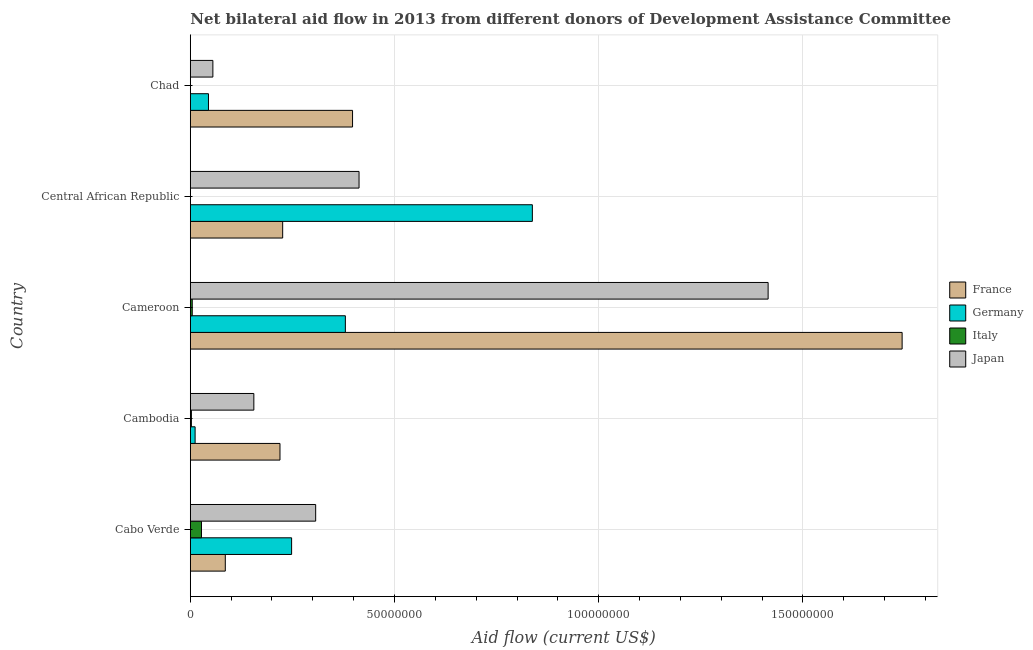How many different coloured bars are there?
Provide a short and direct response. 4. How many groups of bars are there?
Provide a short and direct response. 5. Are the number of bars per tick equal to the number of legend labels?
Give a very brief answer. No. How many bars are there on the 4th tick from the bottom?
Offer a terse response. 3. What is the label of the 5th group of bars from the top?
Your response must be concise. Cabo Verde. In how many cases, is the number of bars for a given country not equal to the number of legend labels?
Provide a succinct answer. 2. What is the amount of aid given by germany in Cambodia?
Make the answer very short. 1.18e+06. Across all countries, what is the maximum amount of aid given by japan?
Offer a very short reply. 1.41e+08. Across all countries, what is the minimum amount of aid given by germany?
Your response must be concise. 1.18e+06. In which country was the amount of aid given by germany maximum?
Keep it short and to the point. Central African Republic. What is the total amount of aid given by france in the graph?
Your response must be concise. 2.67e+08. What is the difference between the amount of aid given by france in Cameroon and that in Chad?
Your response must be concise. 1.35e+08. What is the difference between the amount of aid given by france in Central African Republic and the amount of aid given by germany in Chad?
Your answer should be compact. 1.82e+07. What is the average amount of aid given by japan per country?
Provide a succinct answer. 4.69e+07. What is the difference between the amount of aid given by germany and amount of aid given by japan in Cambodia?
Keep it short and to the point. -1.44e+07. What is the ratio of the amount of aid given by germany in Cabo Verde to that in Cambodia?
Offer a very short reply. 21.02. What is the difference between the highest and the second highest amount of aid given by italy?
Ensure brevity in your answer.  2.26e+06. What is the difference between the highest and the lowest amount of aid given by france?
Provide a short and direct response. 1.66e+08. In how many countries, is the amount of aid given by germany greater than the average amount of aid given by germany taken over all countries?
Your answer should be compact. 2. Are all the bars in the graph horizontal?
Provide a short and direct response. Yes. How many countries are there in the graph?
Make the answer very short. 5. What is the difference between two consecutive major ticks on the X-axis?
Provide a succinct answer. 5.00e+07. Are the values on the major ticks of X-axis written in scientific E-notation?
Give a very brief answer. No. Does the graph contain any zero values?
Make the answer very short. Yes. How many legend labels are there?
Make the answer very short. 4. How are the legend labels stacked?
Your response must be concise. Vertical. What is the title of the graph?
Provide a short and direct response. Net bilateral aid flow in 2013 from different donors of Development Assistance Committee. Does "Coal" appear as one of the legend labels in the graph?
Provide a succinct answer. No. What is the label or title of the Y-axis?
Offer a very short reply. Country. What is the Aid flow (current US$) of France in Cabo Verde?
Keep it short and to the point. 8.57e+06. What is the Aid flow (current US$) in Germany in Cabo Verde?
Offer a terse response. 2.48e+07. What is the Aid flow (current US$) in Italy in Cabo Verde?
Your answer should be compact. 2.74e+06. What is the Aid flow (current US$) in Japan in Cabo Verde?
Your answer should be very brief. 3.07e+07. What is the Aid flow (current US$) of France in Cambodia?
Ensure brevity in your answer.  2.20e+07. What is the Aid flow (current US$) in Germany in Cambodia?
Your answer should be compact. 1.18e+06. What is the Aid flow (current US$) of Japan in Cambodia?
Provide a succinct answer. 1.56e+07. What is the Aid flow (current US$) of France in Cameroon?
Ensure brevity in your answer.  1.74e+08. What is the Aid flow (current US$) in Germany in Cameroon?
Give a very brief answer. 3.80e+07. What is the Aid flow (current US$) of Japan in Cameroon?
Your answer should be very brief. 1.41e+08. What is the Aid flow (current US$) of France in Central African Republic?
Keep it short and to the point. 2.26e+07. What is the Aid flow (current US$) in Germany in Central African Republic?
Offer a terse response. 8.38e+07. What is the Aid flow (current US$) in Italy in Central African Republic?
Give a very brief answer. 0. What is the Aid flow (current US$) of Japan in Central African Republic?
Your answer should be very brief. 4.13e+07. What is the Aid flow (current US$) in France in Chad?
Keep it short and to the point. 3.97e+07. What is the Aid flow (current US$) of Germany in Chad?
Provide a succinct answer. 4.45e+06. What is the Aid flow (current US$) in Japan in Chad?
Provide a succinct answer. 5.53e+06. Across all countries, what is the maximum Aid flow (current US$) in France?
Offer a very short reply. 1.74e+08. Across all countries, what is the maximum Aid flow (current US$) of Germany?
Your answer should be compact. 8.38e+07. Across all countries, what is the maximum Aid flow (current US$) of Italy?
Your response must be concise. 2.74e+06. Across all countries, what is the maximum Aid flow (current US$) in Japan?
Offer a very short reply. 1.41e+08. Across all countries, what is the minimum Aid flow (current US$) of France?
Provide a succinct answer. 8.57e+06. Across all countries, what is the minimum Aid flow (current US$) of Germany?
Your answer should be compact. 1.18e+06. Across all countries, what is the minimum Aid flow (current US$) in Italy?
Provide a succinct answer. 0. Across all countries, what is the minimum Aid flow (current US$) of Japan?
Offer a very short reply. 5.53e+06. What is the total Aid flow (current US$) of France in the graph?
Offer a terse response. 2.67e+08. What is the total Aid flow (current US$) of Germany in the graph?
Your answer should be very brief. 1.52e+08. What is the total Aid flow (current US$) of Italy in the graph?
Keep it short and to the point. 3.49e+06. What is the total Aid flow (current US$) in Japan in the graph?
Make the answer very short. 2.35e+08. What is the difference between the Aid flow (current US$) of France in Cabo Verde and that in Cambodia?
Offer a terse response. -1.34e+07. What is the difference between the Aid flow (current US$) in Germany in Cabo Verde and that in Cambodia?
Offer a terse response. 2.36e+07. What is the difference between the Aid flow (current US$) in Italy in Cabo Verde and that in Cambodia?
Provide a short and direct response. 2.47e+06. What is the difference between the Aid flow (current US$) of Japan in Cabo Verde and that in Cambodia?
Your answer should be very brief. 1.51e+07. What is the difference between the Aid flow (current US$) of France in Cabo Verde and that in Cameroon?
Give a very brief answer. -1.66e+08. What is the difference between the Aid flow (current US$) of Germany in Cabo Verde and that in Cameroon?
Keep it short and to the point. -1.32e+07. What is the difference between the Aid flow (current US$) of Italy in Cabo Verde and that in Cameroon?
Make the answer very short. 2.26e+06. What is the difference between the Aid flow (current US$) in Japan in Cabo Verde and that in Cameroon?
Your answer should be compact. -1.11e+08. What is the difference between the Aid flow (current US$) of France in Cabo Verde and that in Central African Republic?
Your answer should be compact. -1.40e+07. What is the difference between the Aid flow (current US$) of Germany in Cabo Verde and that in Central African Republic?
Make the answer very short. -5.90e+07. What is the difference between the Aid flow (current US$) of Japan in Cabo Verde and that in Central African Republic?
Provide a short and direct response. -1.06e+07. What is the difference between the Aid flow (current US$) in France in Cabo Verde and that in Chad?
Provide a succinct answer. -3.12e+07. What is the difference between the Aid flow (current US$) of Germany in Cabo Verde and that in Chad?
Provide a short and direct response. 2.04e+07. What is the difference between the Aid flow (current US$) in Japan in Cabo Verde and that in Chad?
Keep it short and to the point. 2.52e+07. What is the difference between the Aid flow (current US$) in France in Cambodia and that in Cameroon?
Ensure brevity in your answer.  -1.52e+08. What is the difference between the Aid flow (current US$) of Germany in Cambodia and that in Cameroon?
Your answer should be very brief. -3.68e+07. What is the difference between the Aid flow (current US$) of Japan in Cambodia and that in Cameroon?
Offer a very short reply. -1.26e+08. What is the difference between the Aid flow (current US$) of France in Cambodia and that in Central African Republic?
Make the answer very short. -6.60e+05. What is the difference between the Aid flow (current US$) of Germany in Cambodia and that in Central African Republic?
Your response must be concise. -8.26e+07. What is the difference between the Aid flow (current US$) of Japan in Cambodia and that in Central African Republic?
Make the answer very short. -2.58e+07. What is the difference between the Aid flow (current US$) in France in Cambodia and that in Chad?
Ensure brevity in your answer.  -1.78e+07. What is the difference between the Aid flow (current US$) in Germany in Cambodia and that in Chad?
Provide a succinct answer. -3.27e+06. What is the difference between the Aid flow (current US$) of Japan in Cambodia and that in Chad?
Provide a short and direct response. 1.00e+07. What is the difference between the Aid flow (current US$) in France in Cameroon and that in Central African Republic?
Keep it short and to the point. 1.52e+08. What is the difference between the Aid flow (current US$) in Germany in Cameroon and that in Central African Republic?
Provide a succinct answer. -4.58e+07. What is the difference between the Aid flow (current US$) of Japan in Cameroon and that in Central African Republic?
Your answer should be compact. 1.00e+08. What is the difference between the Aid flow (current US$) in France in Cameroon and that in Chad?
Your response must be concise. 1.35e+08. What is the difference between the Aid flow (current US$) in Germany in Cameroon and that in Chad?
Offer a very short reply. 3.35e+07. What is the difference between the Aid flow (current US$) of Japan in Cameroon and that in Chad?
Make the answer very short. 1.36e+08. What is the difference between the Aid flow (current US$) in France in Central African Republic and that in Chad?
Your answer should be compact. -1.71e+07. What is the difference between the Aid flow (current US$) in Germany in Central African Republic and that in Chad?
Your response must be concise. 7.93e+07. What is the difference between the Aid flow (current US$) of Japan in Central African Republic and that in Chad?
Make the answer very short. 3.58e+07. What is the difference between the Aid flow (current US$) in France in Cabo Verde and the Aid flow (current US$) in Germany in Cambodia?
Offer a very short reply. 7.39e+06. What is the difference between the Aid flow (current US$) in France in Cabo Verde and the Aid flow (current US$) in Italy in Cambodia?
Your answer should be very brief. 8.30e+06. What is the difference between the Aid flow (current US$) of France in Cabo Verde and the Aid flow (current US$) of Japan in Cambodia?
Your answer should be very brief. -6.99e+06. What is the difference between the Aid flow (current US$) of Germany in Cabo Verde and the Aid flow (current US$) of Italy in Cambodia?
Provide a succinct answer. 2.45e+07. What is the difference between the Aid flow (current US$) in Germany in Cabo Verde and the Aid flow (current US$) in Japan in Cambodia?
Keep it short and to the point. 9.25e+06. What is the difference between the Aid flow (current US$) of Italy in Cabo Verde and the Aid flow (current US$) of Japan in Cambodia?
Keep it short and to the point. -1.28e+07. What is the difference between the Aid flow (current US$) in France in Cabo Verde and the Aid flow (current US$) in Germany in Cameroon?
Ensure brevity in your answer.  -2.94e+07. What is the difference between the Aid flow (current US$) of France in Cabo Verde and the Aid flow (current US$) of Italy in Cameroon?
Ensure brevity in your answer.  8.09e+06. What is the difference between the Aid flow (current US$) of France in Cabo Verde and the Aid flow (current US$) of Japan in Cameroon?
Ensure brevity in your answer.  -1.33e+08. What is the difference between the Aid flow (current US$) of Germany in Cabo Verde and the Aid flow (current US$) of Italy in Cameroon?
Your response must be concise. 2.43e+07. What is the difference between the Aid flow (current US$) of Germany in Cabo Verde and the Aid flow (current US$) of Japan in Cameroon?
Make the answer very short. -1.17e+08. What is the difference between the Aid flow (current US$) in Italy in Cabo Verde and the Aid flow (current US$) in Japan in Cameroon?
Give a very brief answer. -1.39e+08. What is the difference between the Aid flow (current US$) of France in Cabo Verde and the Aid flow (current US$) of Germany in Central African Republic?
Your response must be concise. -7.52e+07. What is the difference between the Aid flow (current US$) of France in Cabo Verde and the Aid flow (current US$) of Japan in Central African Republic?
Provide a short and direct response. -3.28e+07. What is the difference between the Aid flow (current US$) in Germany in Cabo Verde and the Aid flow (current US$) in Japan in Central African Republic?
Offer a very short reply. -1.65e+07. What is the difference between the Aid flow (current US$) of Italy in Cabo Verde and the Aid flow (current US$) of Japan in Central African Republic?
Your answer should be compact. -3.86e+07. What is the difference between the Aid flow (current US$) of France in Cabo Verde and the Aid flow (current US$) of Germany in Chad?
Your answer should be compact. 4.12e+06. What is the difference between the Aid flow (current US$) of France in Cabo Verde and the Aid flow (current US$) of Japan in Chad?
Offer a very short reply. 3.04e+06. What is the difference between the Aid flow (current US$) of Germany in Cabo Verde and the Aid flow (current US$) of Japan in Chad?
Keep it short and to the point. 1.93e+07. What is the difference between the Aid flow (current US$) in Italy in Cabo Verde and the Aid flow (current US$) in Japan in Chad?
Your answer should be compact. -2.79e+06. What is the difference between the Aid flow (current US$) of France in Cambodia and the Aid flow (current US$) of Germany in Cameroon?
Your response must be concise. -1.60e+07. What is the difference between the Aid flow (current US$) in France in Cambodia and the Aid flow (current US$) in Italy in Cameroon?
Offer a terse response. 2.15e+07. What is the difference between the Aid flow (current US$) of France in Cambodia and the Aid flow (current US$) of Japan in Cameroon?
Offer a very short reply. -1.20e+08. What is the difference between the Aid flow (current US$) in Germany in Cambodia and the Aid flow (current US$) in Japan in Cameroon?
Your answer should be very brief. -1.40e+08. What is the difference between the Aid flow (current US$) in Italy in Cambodia and the Aid flow (current US$) in Japan in Cameroon?
Offer a very short reply. -1.41e+08. What is the difference between the Aid flow (current US$) in France in Cambodia and the Aid flow (current US$) in Germany in Central African Republic?
Your answer should be very brief. -6.18e+07. What is the difference between the Aid flow (current US$) of France in Cambodia and the Aid flow (current US$) of Japan in Central African Republic?
Your response must be concise. -1.94e+07. What is the difference between the Aid flow (current US$) in Germany in Cambodia and the Aid flow (current US$) in Japan in Central African Republic?
Give a very brief answer. -4.01e+07. What is the difference between the Aid flow (current US$) in Italy in Cambodia and the Aid flow (current US$) in Japan in Central African Republic?
Your response must be concise. -4.10e+07. What is the difference between the Aid flow (current US$) of France in Cambodia and the Aid flow (current US$) of Germany in Chad?
Provide a short and direct response. 1.75e+07. What is the difference between the Aid flow (current US$) in France in Cambodia and the Aid flow (current US$) in Japan in Chad?
Ensure brevity in your answer.  1.64e+07. What is the difference between the Aid flow (current US$) of Germany in Cambodia and the Aid flow (current US$) of Japan in Chad?
Provide a short and direct response. -4.35e+06. What is the difference between the Aid flow (current US$) of Italy in Cambodia and the Aid flow (current US$) of Japan in Chad?
Provide a succinct answer. -5.26e+06. What is the difference between the Aid flow (current US$) in France in Cameroon and the Aid flow (current US$) in Germany in Central African Republic?
Ensure brevity in your answer.  9.05e+07. What is the difference between the Aid flow (current US$) in France in Cameroon and the Aid flow (current US$) in Japan in Central African Republic?
Offer a terse response. 1.33e+08. What is the difference between the Aid flow (current US$) of Germany in Cameroon and the Aid flow (current US$) of Japan in Central African Republic?
Your answer should be very brief. -3.35e+06. What is the difference between the Aid flow (current US$) of Italy in Cameroon and the Aid flow (current US$) of Japan in Central African Republic?
Ensure brevity in your answer.  -4.08e+07. What is the difference between the Aid flow (current US$) of France in Cameroon and the Aid flow (current US$) of Germany in Chad?
Ensure brevity in your answer.  1.70e+08. What is the difference between the Aid flow (current US$) of France in Cameroon and the Aid flow (current US$) of Japan in Chad?
Keep it short and to the point. 1.69e+08. What is the difference between the Aid flow (current US$) in Germany in Cameroon and the Aid flow (current US$) in Japan in Chad?
Ensure brevity in your answer.  3.24e+07. What is the difference between the Aid flow (current US$) in Italy in Cameroon and the Aid flow (current US$) in Japan in Chad?
Your answer should be very brief. -5.05e+06. What is the difference between the Aid flow (current US$) of France in Central African Republic and the Aid flow (current US$) of Germany in Chad?
Keep it short and to the point. 1.82e+07. What is the difference between the Aid flow (current US$) of France in Central African Republic and the Aid flow (current US$) of Japan in Chad?
Make the answer very short. 1.71e+07. What is the difference between the Aid flow (current US$) of Germany in Central African Republic and the Aid flow (current US$) of Japan in Chad?
Offer a terse response. 7.82e+07. What is the average Aid flow (current US$) of France per country?
Provide a short and direct response. 5.34e+07. What is the average Aid flow (current US$) of Germany per country?
Provide a short and direct response. 3.04e+07. What is the average Aid flow (current US$) in Italy per country?
Your response must be concise. 6.98e+05. What is the average Aid flow (current US$) in Japan per country?
Your answer should be very brief. 4.69e+07. What is the difference between the Aid flow (current US$) in France and Aid flow (current US$) in Germany in Cabo Verde?
Provide a short and direct response. -1.62e+07. What is the difference between the Aid flow (current US$) of France and Aid flow (current US$) of Italy in Cabo Verde?
Ensure brevity in your answer.  5.83e+06. What is the difference between the Aid flow (current US$) in France and Aid flow (current US$) in Japan in Cabo Verde?
Your response must be concise. -2.21e+07. What is the difference between the Aid flow (current US$) of Germany and Aid flow (current US$) of Italy in Cabo Verde?
Keep it short and to the point. 2.21e+07. What is the difference between the Aid flow (current US$) in Germany and Aid flow (current US$) in Japan in Cabo Verde?
Offer a very short reply. -5.89e+06. What is the difference between the Aid flow (current US$) of Italy and Aid flow (current US$) of Japan in Cabo Verde?
Provide a short and direct response. -2.80e+07. What is the difference between the Aid flow (current US$) in France and Aid flow (current US$) in Germany in Cambodia?
Provide a short and direct response. 2.08e+07. What is the difference between the Aid flow (current US$) of France and Aid flow (current US$) of Italy in Cambodia?
Provide a short and direct response. 2.17e+07. What is the difference between the Aid flow (current US$) in France and Aid flow (current US$) in Japan in Cambodia?
Offer a very short reply. 6.40e+06. What is the difference between the Aid flow (current US$) of Germany and Aid flow (current US$) of Italy in Cambodia?
Your answer should be compact. 9.10e+05. What is the difference between the Aid flow (current US$) of Germany and Aid flow (current US$) of Japan in Cambodia?
Your response must be concise. -1.44e+07. What is the difference between the Aid flow (current US$) of Italy and Aid flow (current US$) of Japan in Cambodia?
Provide a short and direct response. -1.53e+07. What is the difference between the Aid flow (current US$) of France and Aid flow (current US$) of Germany in Cameroon?
Keep it short and to the point. 1.36e+08. What is the difference between the Aid flow (current US$) of France and Aid flow (current US$) of Italy in Cameroon?
Keep it short and to the point. 1.74e+08. What is the difference between the Aid flow (current US$) in France and Aid flow (current US$) in Japan in Cameroon?
Offer a very short reply. 3.28e+07. What is the difference between the Aid flow (current US$) in Germany and Aid flow (current US$) in Italy in Cameroon?
Your answer should be compact. 3.75e+07. What is the difference between the Aid flow (current US$) of Germany and Aid flow (current US$) of Japan in Cameroon?
Your answer should be compact. -1.04e+08. What is the difference between the Aid flow (current US$) of Italy and Aid flow (current US$) of Japan in Cameroon?
Offer a terse response. -1.41e+08. What is the difference between the Aid flow (current US$) in France and Aid flow (current US$) in Germany in Central African Republic?
Ensure brevity in your answer.  -6.11e+07. What is the difference between the Aid flow (current US$) of France and Aid flow (current US$) of Japan in Central African Republic?
Keep it short and to the point. -1.87e+07. What is the difference between the Aid flow (current US$) in Germany and Aid flow (current US$) in Japan in Central African Republic?
Make the answer very short. 4.24e+07. What is the difference between the Aid flow (current US$) of France and Aid flow (current US$) of Germany in Chad?
Provide a succinct answer. 3.53e+07. What is the difference between the Aid flow (current US$) of France and Aid flow (current US$) of Japan in Chad?
Offer a very short reply. 3.42e+07. What is the difference between the Aid flow (current US$) of Germany and Aid flow (current US$) of Japan in Chad?
Offer a terse response. -1.08e+06. What is the ratio of the Aid flow (current US$) in France in Cabo Verde to that in Cambodia?
Your answer should be very brief. 0.39. What is the ratio of the Aid flow (current US$) in Germany in Cabo Verde to that in Cambodia?
Offer a terse response. 21.03. What is the ratio of the Aid flow (current US$) of Italy in Cabo Verde to that in Cambodia?
Give a very brief answer. 10.15. What is the ratio of the Aid flow (current US$) in Japan in Cabo Verde to that in Cambodia?
Provide a succinct answer. 1.97. What is the ratio of the Aid flow (current US$) in France in Cabo Verde to that in Cameroon?
Make the answer very short. 0.05. What is the ratio of the Aid flow (current US$) in Germany in Cabo Verde to that in Cameroon?
Keep it short and to the point. 0.65. What is the ratio of the Aid flow (current US$) in Italy in Cabo Verde to that in Cameroon?
Make the answer very short. 5.71. What is the ratio of the Aid flow (current US$) of Japan in Cabo Verde to that in Cameroon?
Offer a terse response. 0.22. What is the ratio of the Aid flow (current US$) of France in Cabo Verde to that in Central African Republic?
Provide a short and direct response. 0.38. What is the ratio of the Aid flow (current US$) of Germany in Cabo Verde to that in Central African Republic?
Provide a short and direct response. 0.3. What is the ratio of the Aid flow (current US$) of Japan in Cabo Verde to that in Central African Republic?
Give a very brief answer. 0.74. What is the ratio of the Aid flow (current US$) in France in Cabo Verde to that in Chad?
Provide a short and direct response. 0.22. What is the ratio of the Aid flow (current US$) in Germany in Cabo Verde to that in Chad?
Your answer should be very brief. 5.58. What is the ratio of the Aid flow (current US$) in Japan in Cabo Verde to that in Chad?
Your answer should be compact. 5.55. What is the ratio of the Aid flow (current US$) in France in Cambodia to that in Cameroon?
Make the answer very short. 0.13. What is the ratio of the Aid flow (current US$) in Germany in Cambodia to that in Cameroon?
Your answer should be very brief. 0.03. What is the ratio of the Aid flow (current US$) of Italy in Cambodia to that in Cameroon?
Provide a succinct answer. 0.56. What is the ratio of the Aid flow (current US$) in Japan in Cambodia to that in Cameroon?
Your response must be concise. 0.11. What is the ratio of the Aid flow (current US$) in France in Cambodia to that in Central African Republic?
Ensure brevity in your answer.  0.97. What is the ratio of the Aid flow (current US$) of Germany in Cambodia to that in Central African Republic?
Your answer should be very brief. 0.01. What is the ratio of the Aid flow (current US$) of Japan in Cambodia to that in Central African Republic?
Offer a terse response. 0.38. What is the ratio of the Aid flow (current US$) of France in Cambodia to that in Chad?
Offer a very short reply. 0.55. What is the ratio of the Aid flow (current US$) of Germany in Cambodia to that in Chad?
Provide a succinct answer. 0.27. What is the ratio of the Aid flow (current US$) of Japan in Cambodia to that in Chad?
Offer a terse response. 2.81. What is the ratio of the Aid flow (current US$) in France in Cameroon to that in Central African Republic?
Your answer should be very brief. 7.71. What is the ratio of the Aid flow (current US$) in Germany in Cameroon to that in Central African Republic?
Make the answer very short. 0.45. What is the ratio of the Aid flow (current US$) of Japan in Cameroon to that in Central African Republic?
Keep it short and to the point. 3.42. What is the ratio of the Aid flow (current US$) in France in Cameroon to that in Chad?
Your response must be concise. 4.39. What is the ratio of the Aid flow (current US$) in Germany in Cameroon to that in Chad?
Give a very brief answer. 8.53. What is the ratio of the Aid flow (current US$) of Japan in Cameroon to that in Chad?
Your answer should be very brief. 25.59. What is the ratio of the Aid flow (current US$) of France in Central African Republic to that in Chad?
Ensure brevity in your answer.  0.57. What is the ratio of the Aid flow (current US$) of Germany in Central African Republic to that in Chad?
Keep it short and to the point. 18.82. What is the ratio of the Aid flow (current US$) in Japan in Central African Republic to that in Chad?
Provide a succinct answer. 7.47. What is the difference between the highest and the second highest Aid flow (current US$) of France?
Give a very brief answer. 1.35e+08. What is the difference between the highest and the second highest Aid flow (current US$) of Germany?
Provide a succinct answer. 4.58e+07. What is the difference between the highest and the second highest Aid flow (current US$) of Italy?
Offer a very short reply. 2.26e+06. What is the difference between the highest and the second highest Aid flow (current US$) of Japan?
Give a very brief answer. 1.00e+08. What is the difference between the highest and the lowest Aid flow (current US$) of France?
Your response must be concise. 1.66e+08. What is the difference between the highest and the lowest Aid flow (current US$) in Germany?
Offer a very short reply. 8.26e+07. What is the difference between the highest and the lowest Aid flow (current US$) of Italy?
Your answer should be very brief. 2.74e+06. What is the difference between the highest and the lowest Aid flow (current US$) of Japan?
Provide a short and direct response. 1.36e+08. 